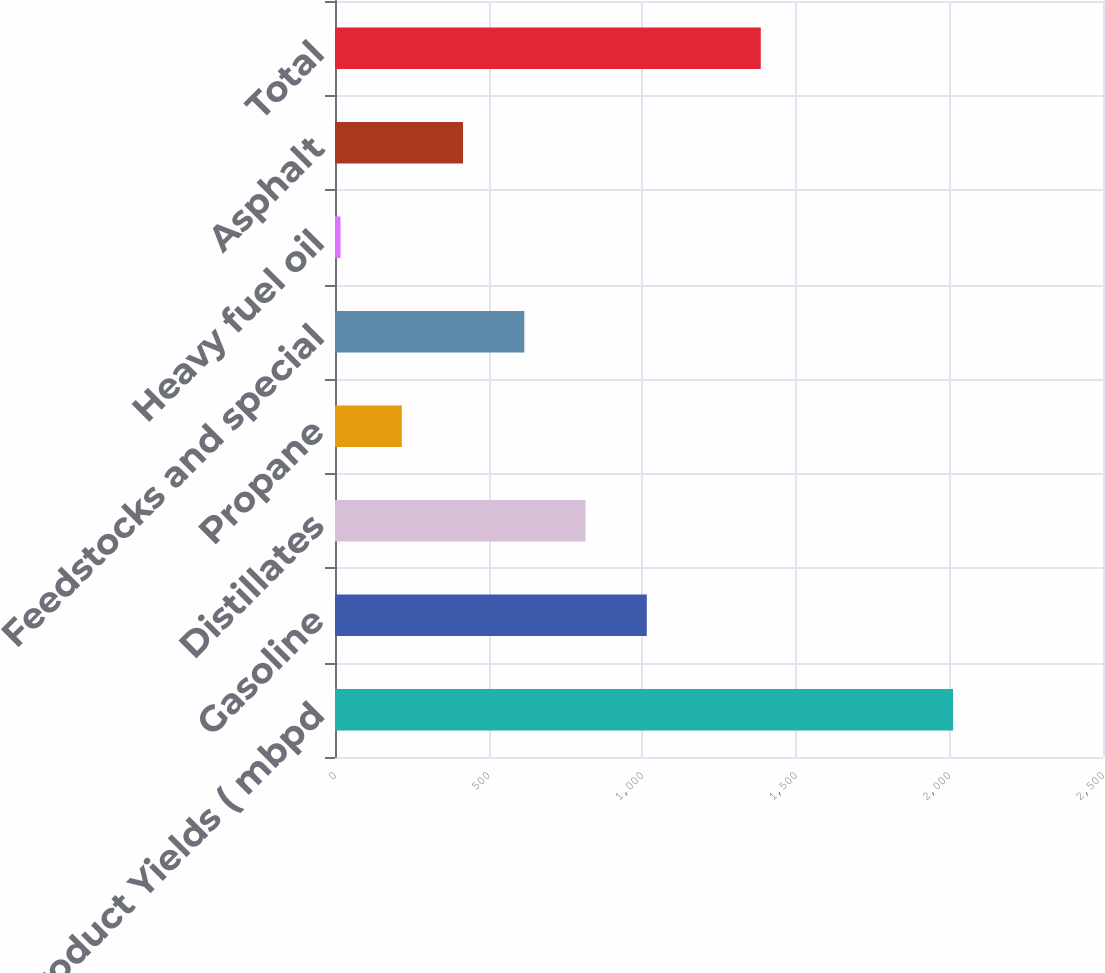Convert chart to OTSL. <chart><loc_0><loc_0><loc_500><loc_500><bar_chart><fcel>Refined Product Yields ( mbpd<fcel>Gasoline<fcel>Distillates<fcel>Propane<fcel>Feedstocks and special<fcel>Heavy fuel oil<fcel>Asphalt<fcel>Total<nl><fcel>2012<fcel>1015<fcel>815.6<fcel>217.4<fcel>616.2<fcel>18<fcel>416.8<fcel>1386<nl></chart> 